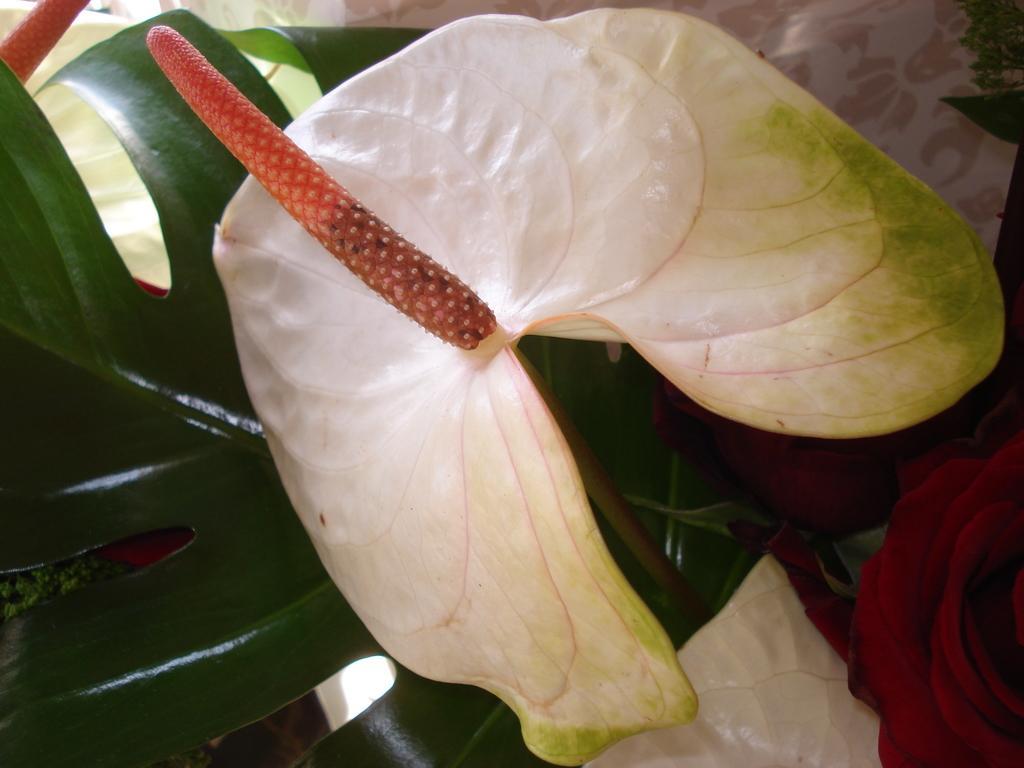How would you summarize this image in a sentence or two? Here in this picture we can see a plant present and in the middle we can see a white colored fruit with something in orange colored present in the middle over there. 